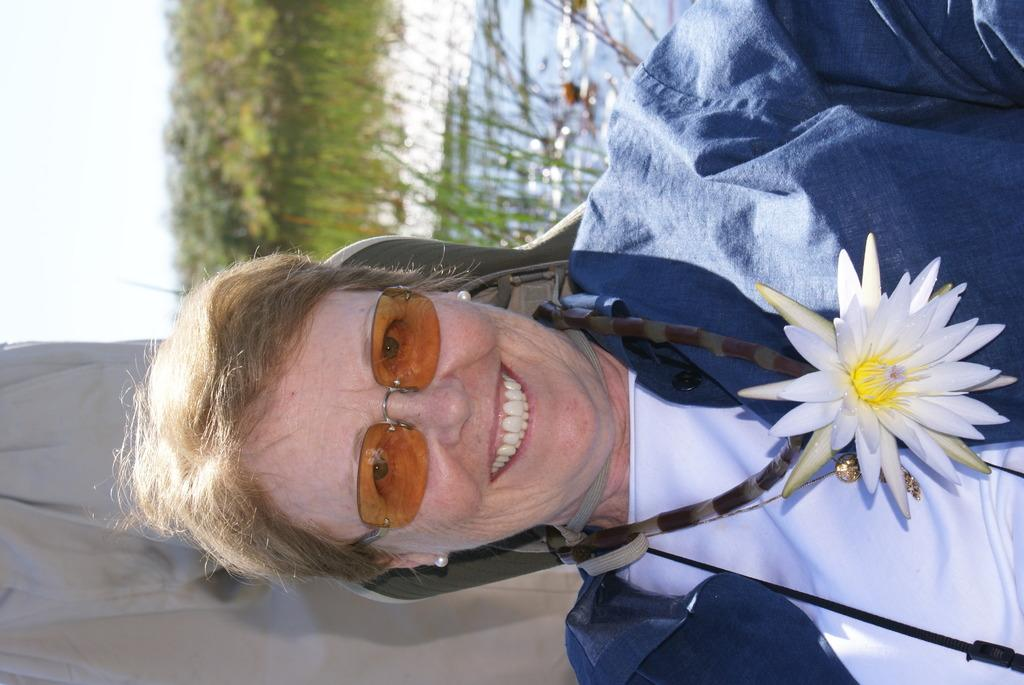Who is the main subject in the image? There is a woman in the image. What is the woman wearing on her face? The woman is wearing goggles. What is the woman's facial expression? The woman is smiling. What can be seen in the background of the image? There are trees and water visible in the background of the image. What is located behind the woman? There is an object behind the woman. What type of medical advice is the woman giving to her son in the image? There is no son present in the image, and the woman is not depicted as giving any medical advice. What is the woman's crush doing in the image? There is no mention of a crush in the image, and no one else is present in the image. 